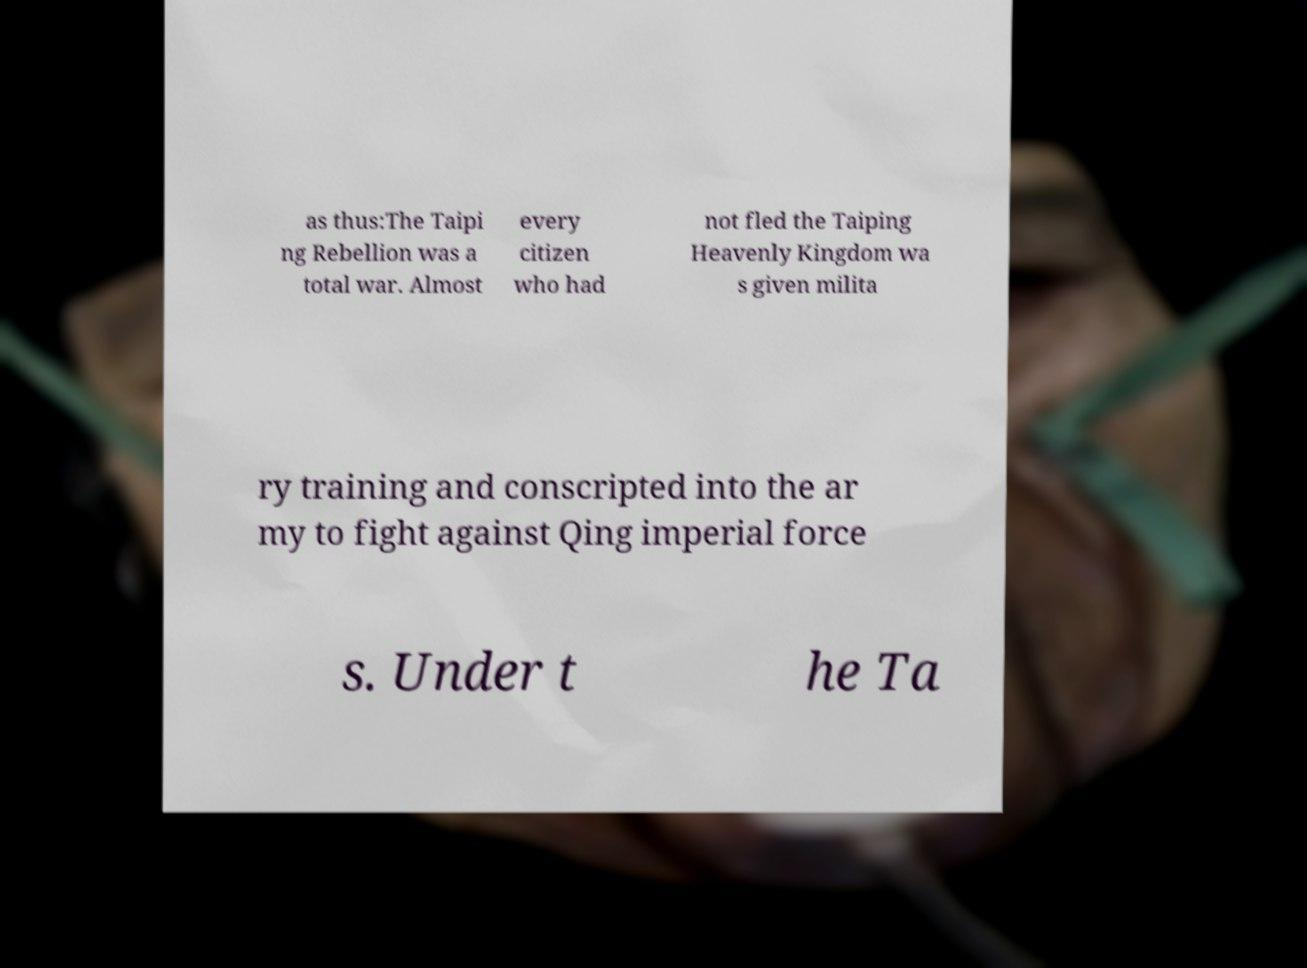What messages or text are displayed in this image? I need them in a readable, typed format. as thus:The Taipi ng Rebellion was a total war. Almost every citizen who had not fled the Taiping Heavenly Kingdom wa s given milita ry training and conscripted into the ar my to fight against Qing imperial force s. Under t he Ta 